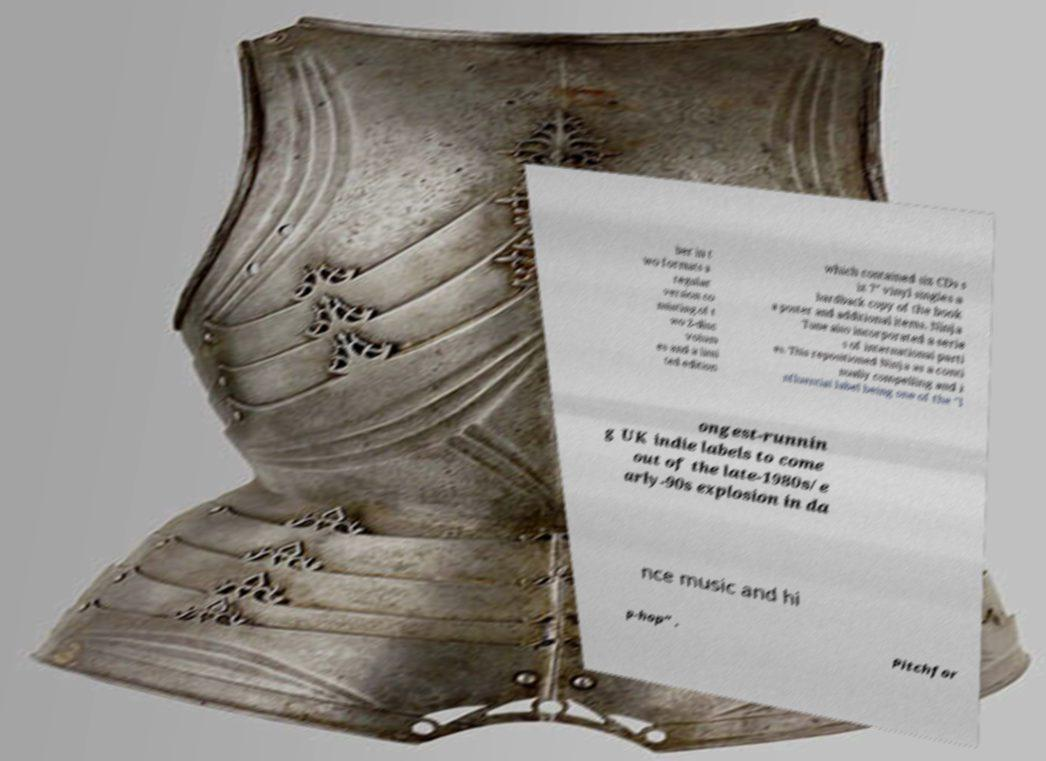What messages or text are displayed in this image? I need them in a readable, typed format. ber in t wo formats a regular version co nsisting of t wo 2-disc volum es and a limi ted edition which contained six CDs s ix 7" vinyl singles a hardback copy of the book a poster and additional items. Ninja Tune also incorporated a serie s of international parti es. This repositioned Ninja as a conti nually compelling and i nfluential label being one of the "l ongest-runnin g UK indie labels to come out of the late-1980s/e arly-90s explosion in da nce music and hi p-hop" . Pitchfor 